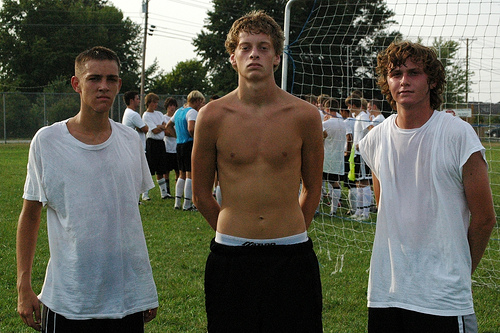<image>
Is there a white underwear behind the black trousers? Yes. From this viewpoint, the white underwear is positioned behind the black trousers, with the black trousers partially or fully occluding the white underwear. 